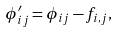<formula> <loc_0><loc_0><loc_500><loc_500>\phi ^ { \prime } _ { i j } = \phi _ { i j } - f _ { i , j } ,</formula> 